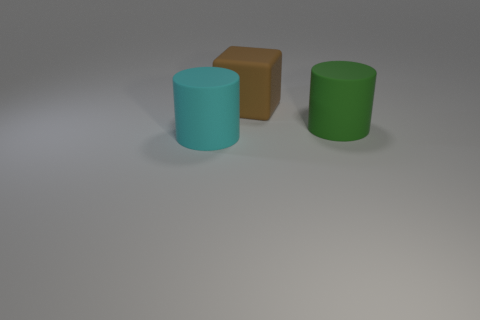Add 1 green objects. How many objects exist? 4 Subtract all cylinders. How many objects are left? 1 Subtract all matte objects. Subtract all brown metallic cylinders. How many objects are left? 0 Add 1 big matte blocks. How many big matte blocks are left? 2 Add 3 tiny cyan things. How many tiny cyan things exist? 3 Subtract 0 cyan cubes. How many objects are left? 3 